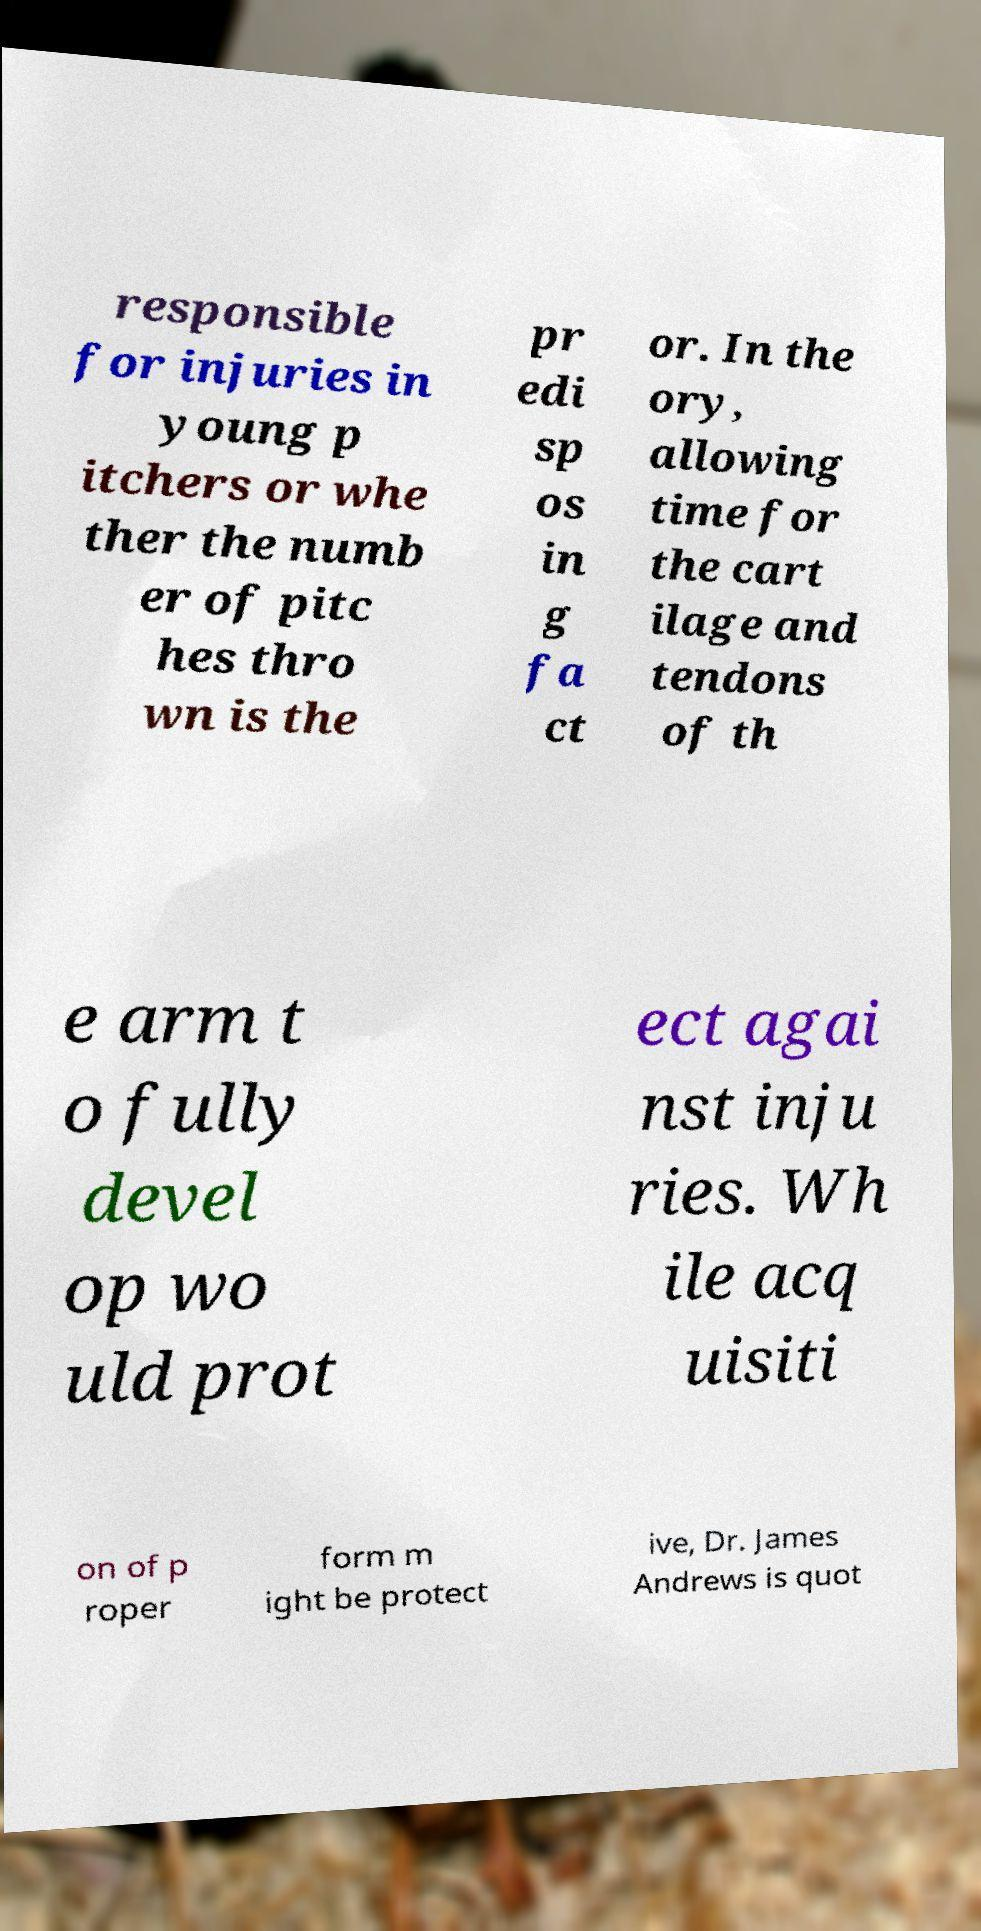Please identify and transcribe the text found in this image. responsible for injuries in young p itchers or whe ther the numb er of pitc hes thro wn is the pr edi sp os in g fa ct or. In the ory, allowing time for the cart ilage and tendons of th e arm t o fully devel op wo uld prot ect agai nst inju ries. Wh ile acq uisiti on of p roper form m ight be protect ive, Dr. James Andrews is quot 